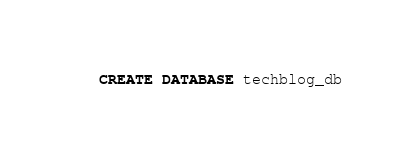<code> <loc_0><loc_0><loc_500><loc_500><_SQL_>CREATE DATABASE techblog_db
</code> 